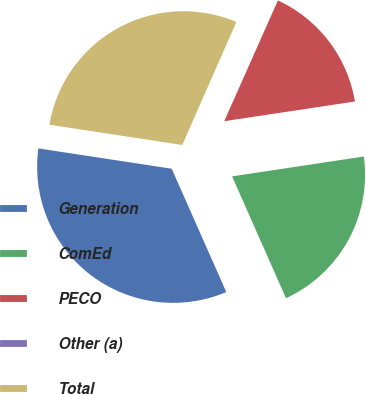Convert chart. <chart><loc_0><loc_0><loc_500><loc_500><pie_chart><fcel>Generation<fcel>ComEd<fcel>PECO<fcel>Other (a)<fcel>Total<nl><fcel>34.04%<fcel>20.75%<fcel>15.96%<fcel>0.06%<fcel>29.19%<nl></chart> 